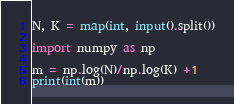<code> <loc_0><loc_0><loc_500><loc_500><_Python_>N, K = map(int, input().split())

import numpy as np

m = np.log(N)/np.log(K) +1
print(int(m))</code> 